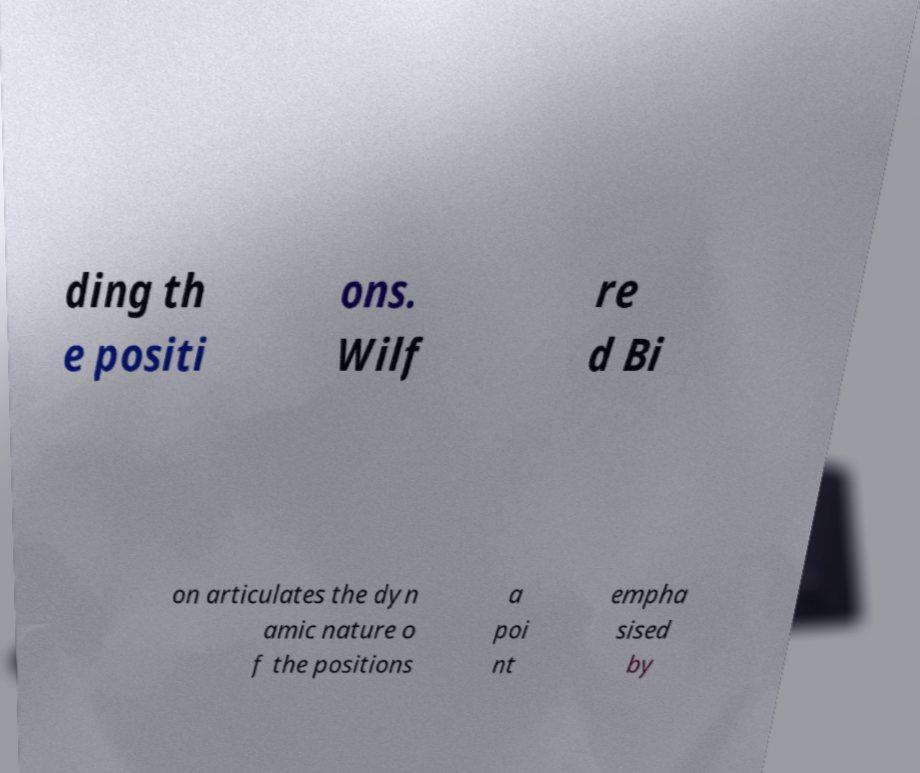I need the written content from this picture converted into text. Can you do that? ding th e positi ons. Wilf re d Bi on articulates the dyn amic nature o f the positions a poi nt empha sised by 